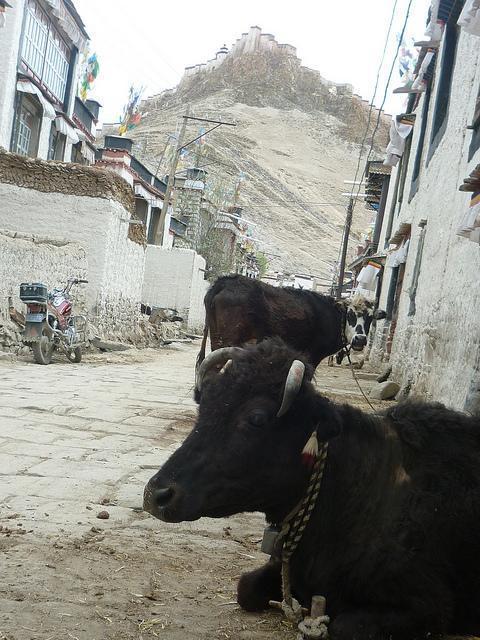How many animals are alive?
Give a very brief answer. 2. How many cows are visible?
Give a very brief answer. 2. How many of these bottles have yellow on the lid?
Give a very brief answer. 0. 